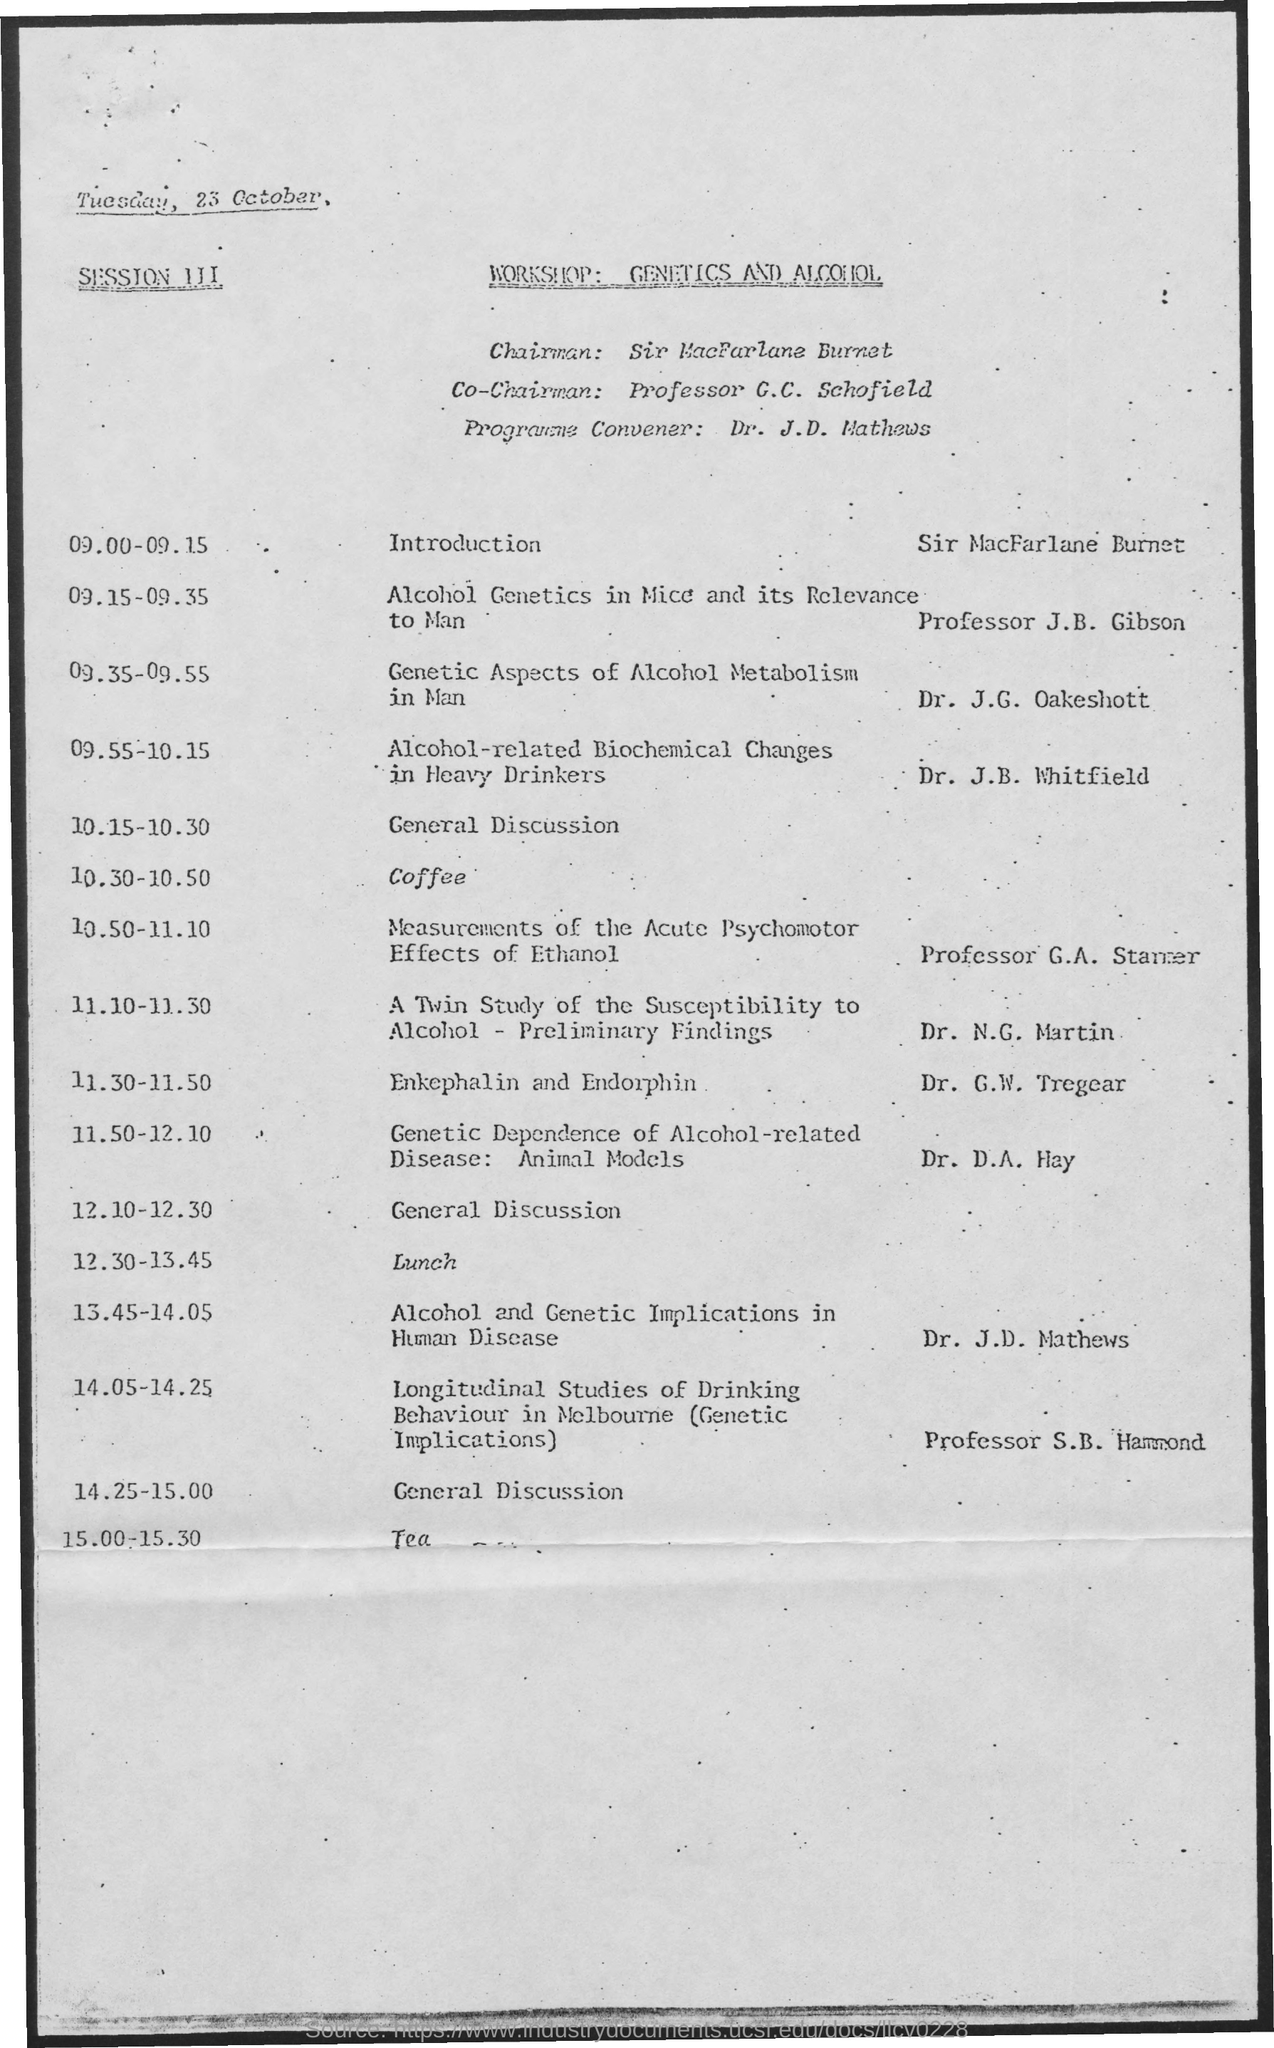Who is the chairman for the given workshop ?
Ensure brevity in your answer.  Sir mACfARLANE bURNET. Who is the program convener for the given workshop ?
Your answer should be very brief. Dr. J.D. Mathews. What is the schedule at the time of 9.00 - 9.15 as mentioned in the given agenda ?
Give a very brief answer. Introduction. What is the schedule at the time of 10.15-10.30 as mentioned in the given agenda ?
Make the answer very short. General Discussion. What is the schedule at the time of 10.30-10.50 as mentioned in the given agenda ?
Provide a succinct answer. Coffee. What is the schedule at the time of 12.30-13.45 as mentioned in the given agenda ?
Your answer should be compact. Lunch. What is the schedule at the time of 15.00-15.30 as mentioned in the given agenda ?
Provide a succinct answer. Tea. 